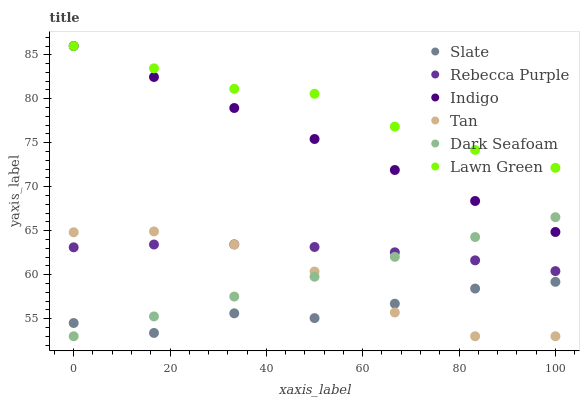Does Slate have the minimum area under the curve?
Answer yes or no. Yes. Does Lawn Green have the maximum area under the curve?
Answer yes or no. Yes. Does Indigo have the minimum area under the curve?
Answer yes or no. No. Does Indigo have the maximum area under the curve?
Answer yes or no. No. Is Dark Seafoam the smoothest?
Answer yes or no. Yes. Is Tan the roughest?
Answer yes or no. Yes. Is Indigo the smoothest?
Answer yes or no. No. Is Indigo the roughest?
Answer yes or no. No. Does Dark Seafoam have the lowest value?
Answer yes or no. Yes. Does Indigo have the lowest value?
Answer yes or no. No. Does Indigo have the highest value?
Answer yes or no. Yes. Does Slate have the highest value?
Answer yes or no. No. Is Slate less than Indigo?
Answer yes or no. Yes. Is Indigo greater than Slate?
Answer yes or no. Yes. Does Dark Seafoam intersect Slate?
Answer yes or no. Yes. Is Dark Seafoam less than Slate?
Answer yes or no. No. Is Dark Seafoam greater than Slate?
Answer yes or no. No. Does Slate intersect Indigo?
Answer yes or no. No. 